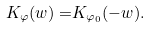<formula> <loc_0><loc_0><loc_500><loc_500>K _ { \varphi } ( w ) = & K _ { \varphi _ { 0 } } ( - w ) .</formula> 